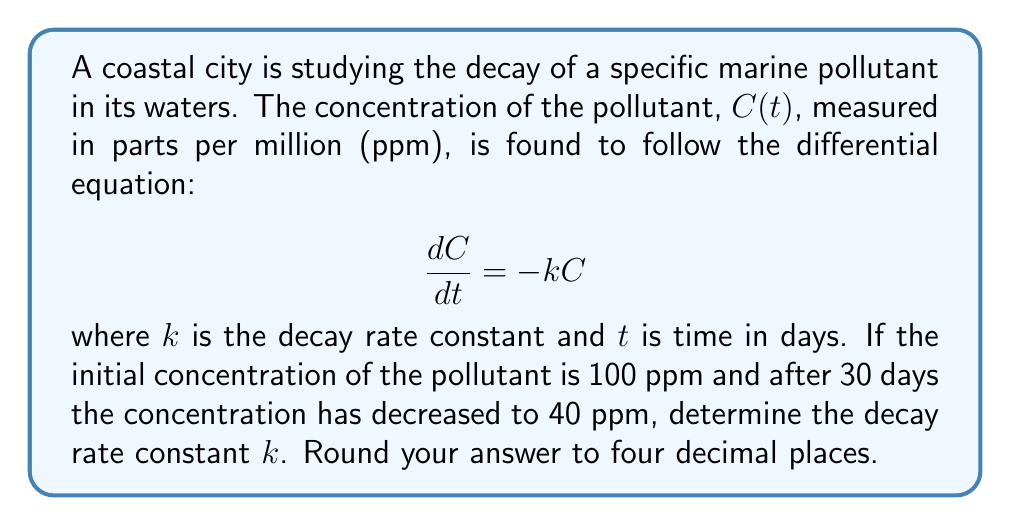Solve this math problem. To solve this problem, we'll follow these steps:

1) The given differential equation is a first-order linear equation with constant coefficients. Its solution is of the form:

   $$C(t) = C_0e^{-kt}$$

   where $C_0$ is the initial concentration.

2) We're given that $C_0 = 100$ ppm and after 30 days, $C(30) = 40$ ppm. Let's substitute these into our equation:

   $$40 = 100e^{-30k}$$

3) Divide both sides by 100:

   $$0.4 = e^{-30k}$$

4) Take the natural logarithm of both sides:

   $$\ln(0.4) = -30k$$

5) Solve for $k$:

   $$k = -\frac{\ln(0.4)}{30}$$

6) Calculate the value (using a calculator):

   $$k = -\frac{-0.916290731874155}{30} = 0.030543024395805$$

7) Rounding to four decimal places:

   $$k \approx 0.0305$$
Answer: $k \approx 0.0305$ day$^{-1}$ 